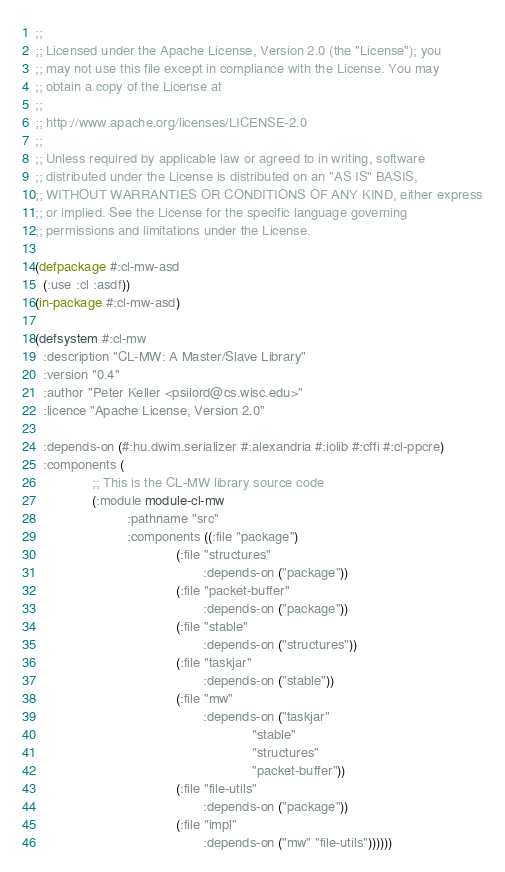Convert code to text. <code><loc_0><loc_0><loc_500><loc_500><_Lisp_>;;
;; Licensed under the Apache License, Version 2.0 (the "License"); you
;; may not use this file except in compliance with the License. You may
;; obtain a copy of the License at
;;
;; http://www.apache.org/licenses/LICENSE-2.0
;;
;; Unless required by applicable law or agreed to in writing, software
;; distributed under the License is distributed on an "AS IS" BASIS,
;; WITHOUT WARRANTIES OR CONDITIONS OF ANY KIND, either express
;; or implied. See the License for the specific language governing
;; permissions and limitations under the License.

(defpackage #:cl-mw-asd
  (:use :cl :asdf))
(in-package #:cl-mw-asd)

(defsystem #:cl-mw
  :description "CL-MW: A Master/Slave Library"
  :version "0.4"
  :author "Peter Keller <psilord@cs.wisc.edu>"
  :licence "Apache License, Version 2.0"

  :depends-on (#:hu.dwim.serializer #:alexandria #:iolib #:cffi #:cl-ppcre)
  :components (
               ;; This is the CL-MW library source code
               (:module module-cl-mw
                        :pathname "src"
                        :components ((:file "package")
                                     (:file "structures"
                                            :depends-on ("package"))
                                     (:file "packet-buffer"
                                            :depends-on ("package"))
                                     (:file "stable"
                                            :depends-on ("structures"))
                                     (:file "taskjar"
                                            :depends-on ("stable"))
                                     (:file "mw"
                                            :depends-on ("taskjar"
                                                         "stable"
                                                         "structures"
                                                         "packet-buffer"))
                                     (:file "file-utils"
                                            :depends-on ("package"))
                                     (:file "impl"
                                            :depends-on ("mw" "file-utils"))))))
</code> 